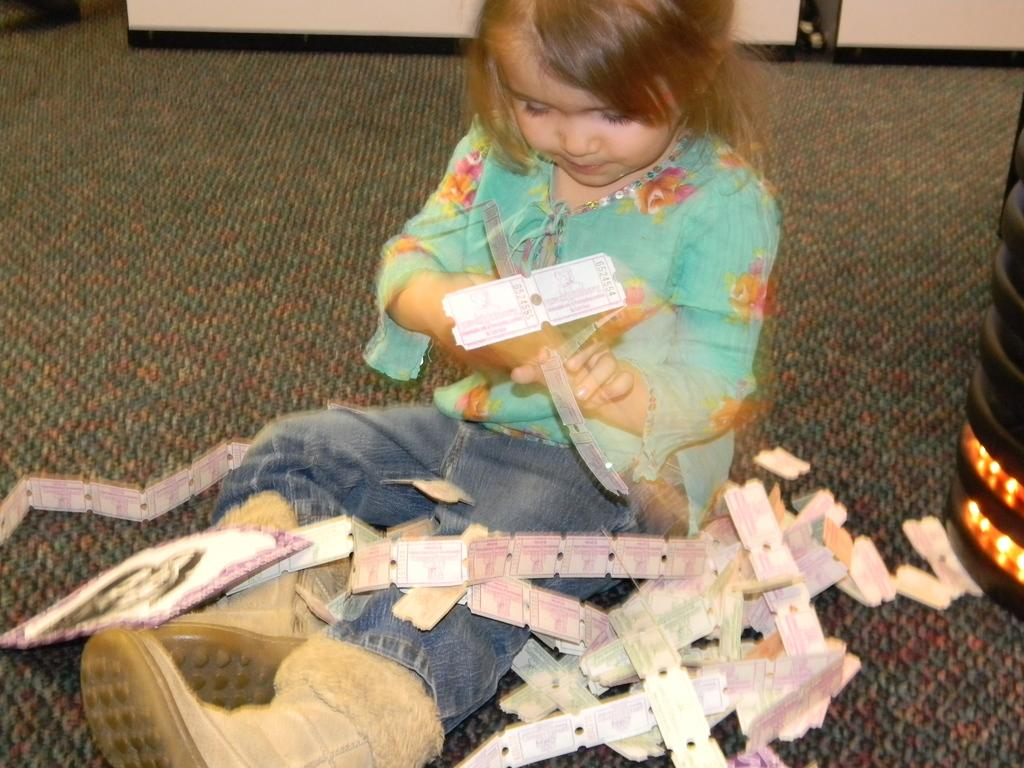Who is the main subject in the image? There is a small girl in the image. What is the girl doing in the image? The girl is playing in the image. Where is the girl sitting in the image? The girl is sitting on a rug in the image. How is the girl positioned in the image? The girl is in the center of the image. Who is the creator of the rug the girl is sitting on in the image? The facts provided do not give any information about the creator of the rug, so we cannot answer that question. 